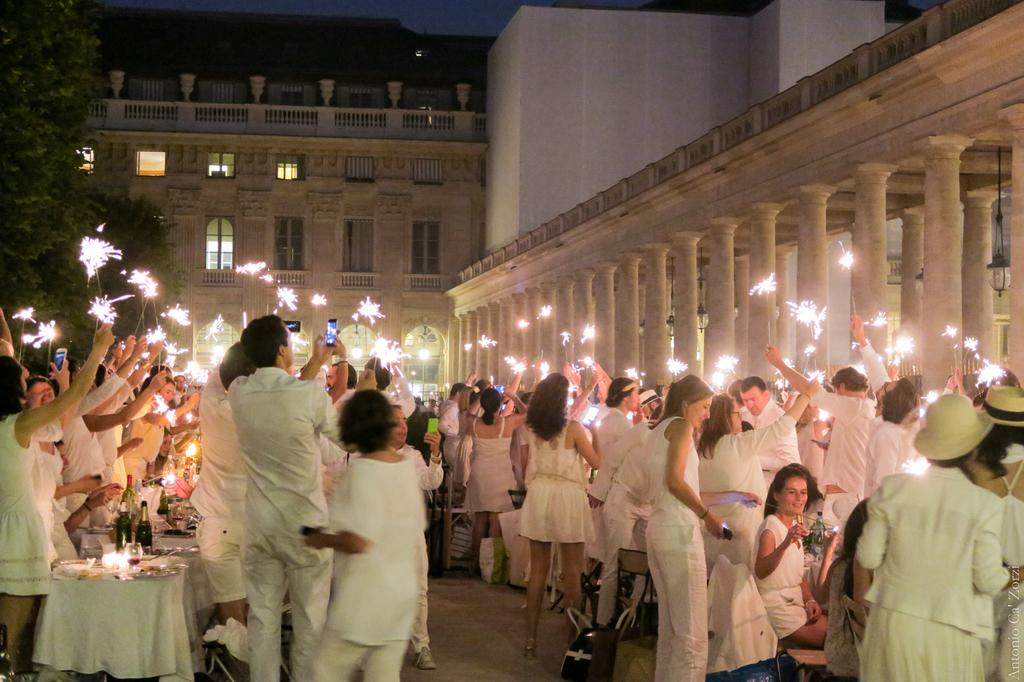How many people are in the image? There are people in the image, but the exact number is not specified. What are the people doing in the image? The people are standing and taking pictures. What is located in the middle of the image? There is a building in the image, and it is in the middle. What can be seen on the left side of the image? There is a tree on the left side of the image. What type of feast is being prepared in the building in the image? There is no indication of a feast being prepared in the building in the image. Can you tell me how many jail cells are visible in the image? There is no mention of a jail or jail cells in the image. 